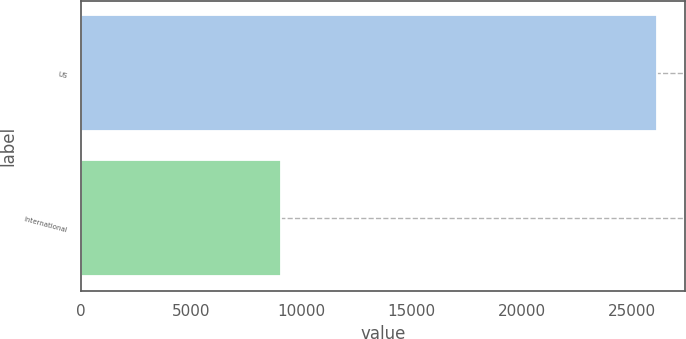Convert chart to OTSL. <chart><loc_0><loc_0><loc_500><loc_500><bar_chart><fcel>US<fcel>International<nl><fcel>26132<fcel>9082<nl></chart> 